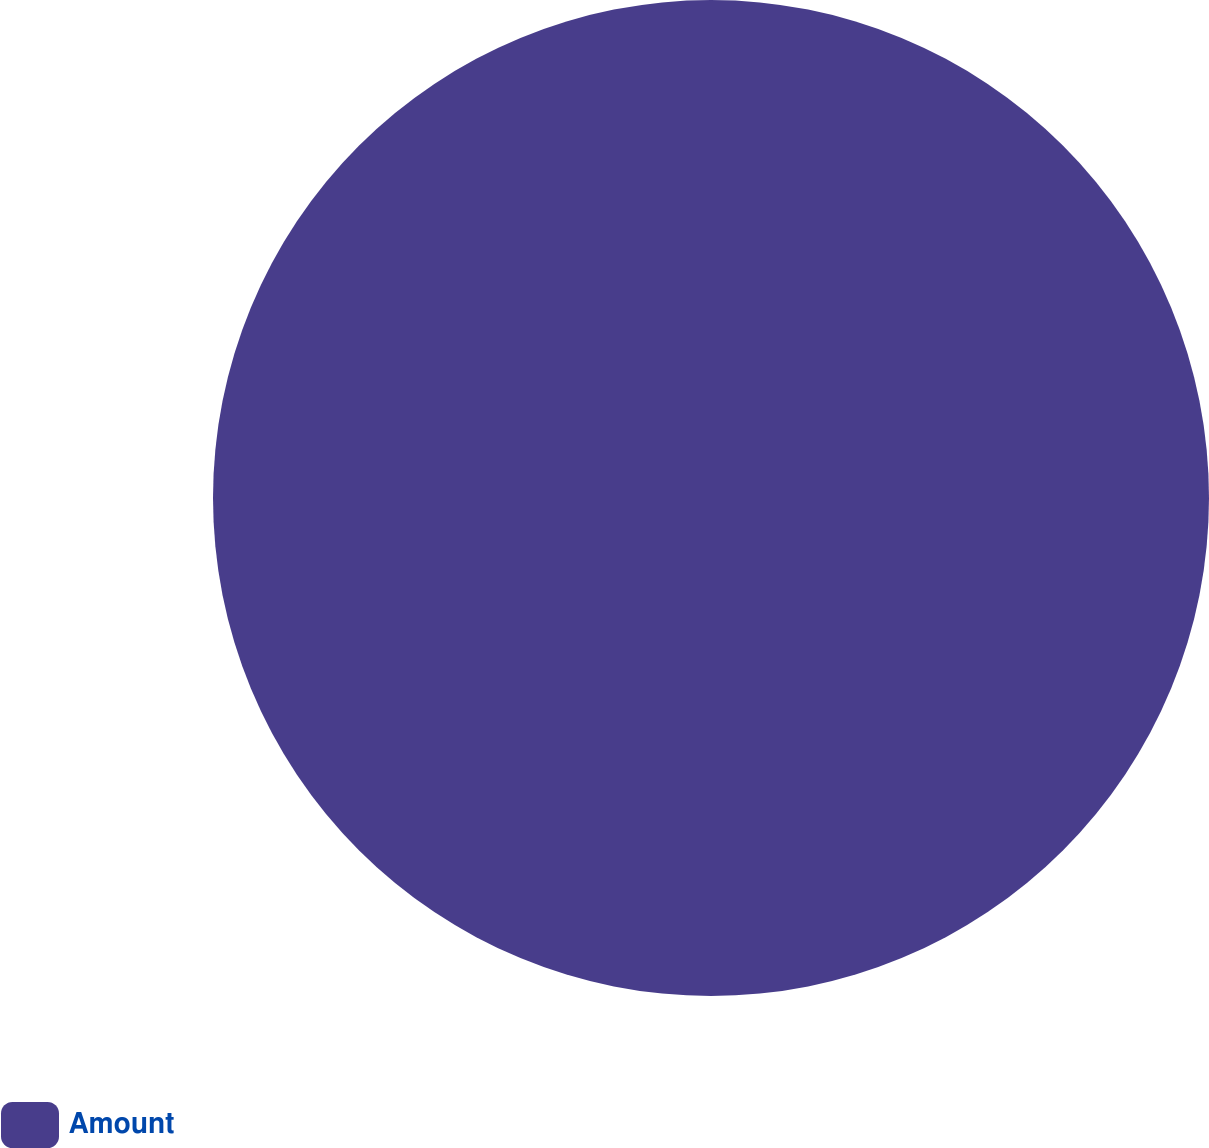Convert chart. <chart><loc_0><loc_0><loc_500><loc_500><pie_chart><fcel>Amount<nl><fcel>100.0%<nl></chart> 